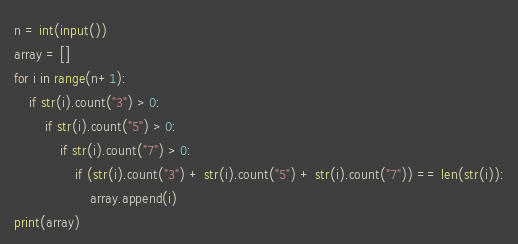<code> <loc_0><loc_0><loc_500><loc_500><_Python_>n = int(input())
array = []
for i in range(n+1):
    if str(i).count("3") > 0:
        if str(i).count("5") > 0:
            if str(i).count("7") > 0:
                if (str(i).count("3") + str(i).count("5") + str(i).count("7")) == len(str(i)):
                    array.append(i)
print(array)
</code> 